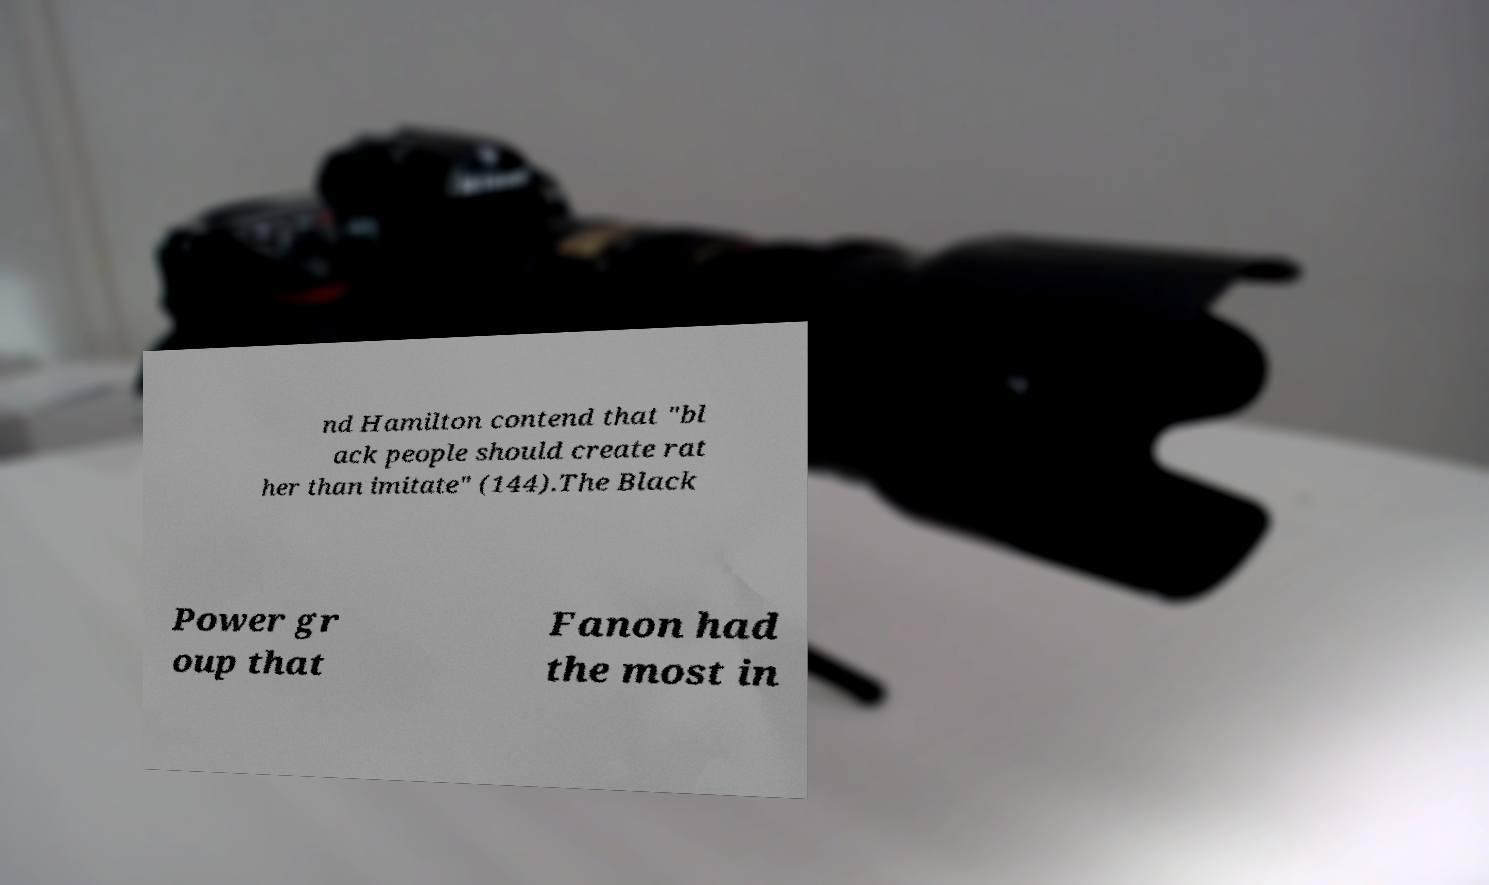There's text embedded in this image that I need extracted. Can you transcribe it verbatim? nd Hamilton contend that "bl ack people should create rat her than imitate" (144).The Black Power gr oup that Fanon had the most in 